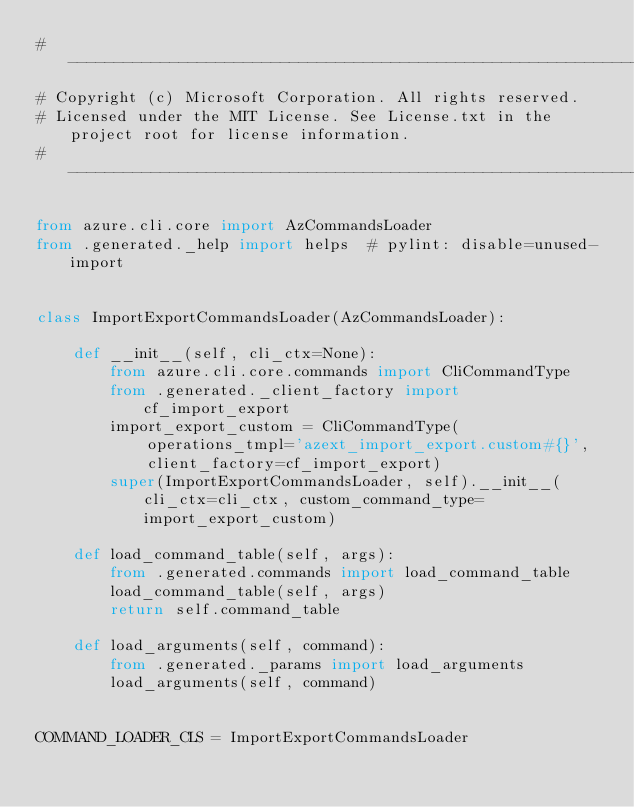Convert code to text. <code><loc_0><loc_0><loc_500><loc_500><_Python_># --------------------------------------------------------------------------------------------
# Copyright (c) Microsoft Corporation. All rights reserved.
# Licensed under the MIT License. See License.txt in the project root for license information.
# --------------------------------------------------------------------------------------------

from azure.cli.core import AzCommandsLoader
from .generated._help import helps  # pylint: disable=unused-import


class ImportExportCommandsLoader(AzCommandsLoader):

    def __init__(self, cli_ctx=None):
        from azure.cli.core.commands import CliCommandType
        from .generated._client_factory import cf_import_export
        import_export_custom = CliCommandType(
            operations_tmpl='azext_import_export.custom#{}',
            client_factory=cf_import_export)
        super(ImportExportCommandsLoader, self).__init__(cli_ctx=cli_ctx, custom_command_type=import_export_custom)

    def load_command_table(self, args):
        from .generated.commands import load_command_table
        load_command_table(self, args)
        return self.command_table

    def load_arguments(self, command):
        from .generated._params import load_arguments
        load_arguments(self, command)


COMMAND_LOADER_CLS = ImportExportCommandsLoader
</code> 